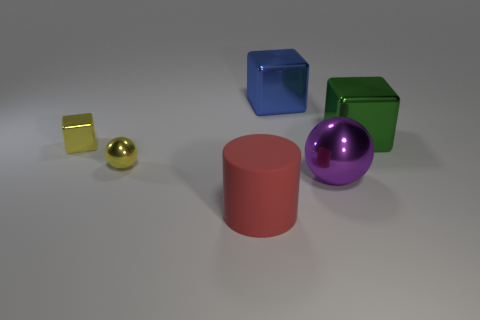Is there a small purple thing that has the same material as the large cylinder?
Offer a very short reply. No. There is a sphere that is the same size as the cylinder; what material is it?
Keep it short and to the point. Metal. Are there fewer big blue shiny objects that are in front of the yellow ball than big purple metallic objects that are in front of the big purple metallic object?
Provide a short and direct response. No. What shape is the big thing that is in front of the large blue metallic thing and on the left side of the big metallic sphere?
Provide a short and direct response. Cylinder. How many other rubber objects are the same shape as the red object?
Provide a short and direct response. 0. What size is the yellow cube that is the same material as the small yellow ball?
Offer a terse response. Small. Is the number of small purple shiny objects greater than the number of large blue shiny blocks?
Your response must be concise. No. There is a block that is behind the green metallic thing; what color is it?
Your response must be concise. Blue. What is the size of the block that is left of the green block and in front of the large blue metal object?
Your answer should be very brief. Small. What number of metallic balls have the same size as the green shiny cube?
Your answer should be very brief. 1. 